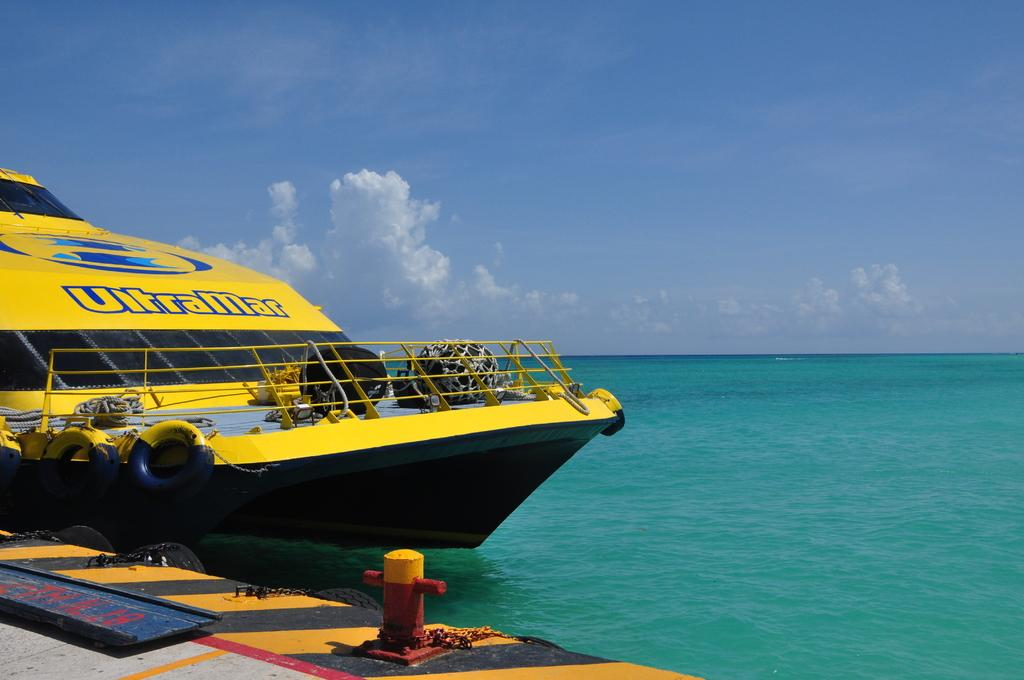<image>
Offer a succinct explanation of the picture presented. A yellow boat with the word Ultra Mar on it. 